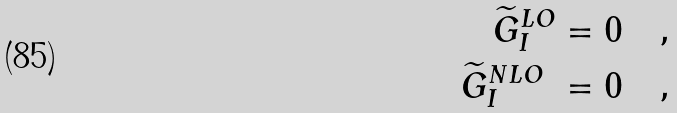Convert formula to latex. <formula><loc_0><loc_0><loc_500><loc_500>\widetilde { G } _ { I } ^ { L O } = 0 \quad , \\ \widetilde { G } _ { I } ^ { N L O } \ = 0 \quad ,</formula> 